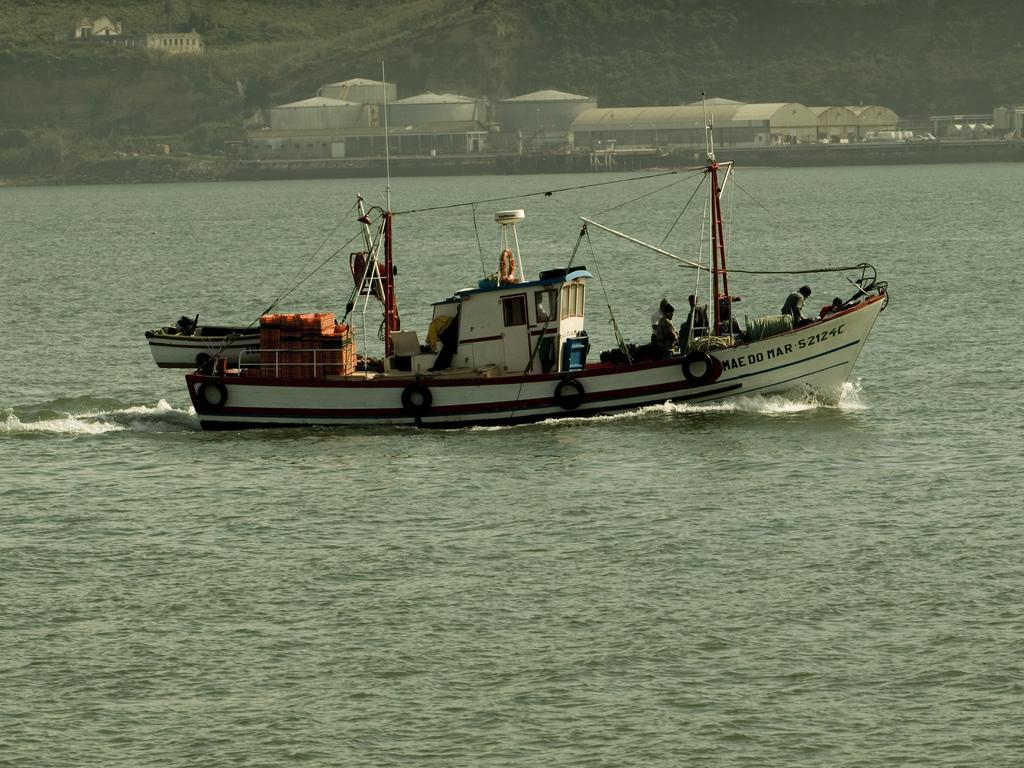What activity are the people in the image engaged in? The people in the image are sailing a boat. Are there any other boats in the image? Yes, there is another boat in the image. What is the primary element in the image? There is water in the image. What structures can be seen at the top of the image? Containers, sheds, trees, plants, and a building are present at the top of the image. How many pages are visible in the image? There are no pages present in the image. Who are the friends sailing with in the image? The facts provided do not mention any friends, only people sailing a boat. 